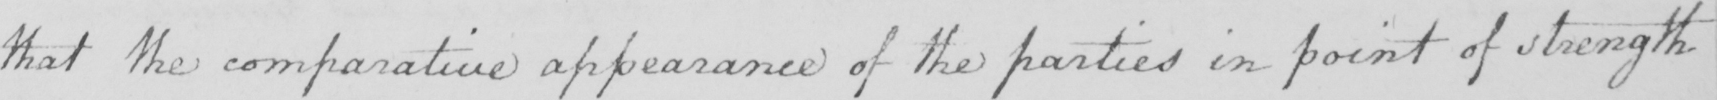Can you read and transcribe this handwriting? that the comparative appearance of the parties in point of strength 